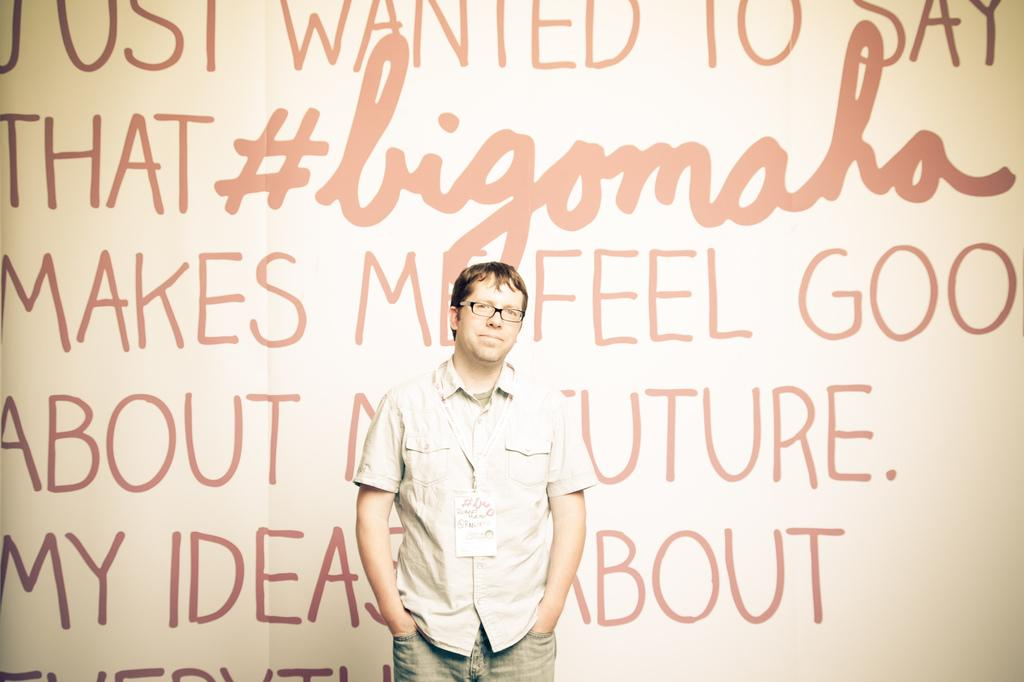What is the main subject of the image? There is a man standing in the image. What is the man wearing in the image? The man is wearing an ID card and spectacles. What can be seen in the background of the image? There is text visible in the background of the image. What type of hook is the man using to perform an operation in the image? There is no hook or operation being performed in the image; the man is simply standing and wearing an ID card and spectacles. Is there any sand visible in the image? No, there is no sand present in the image. 